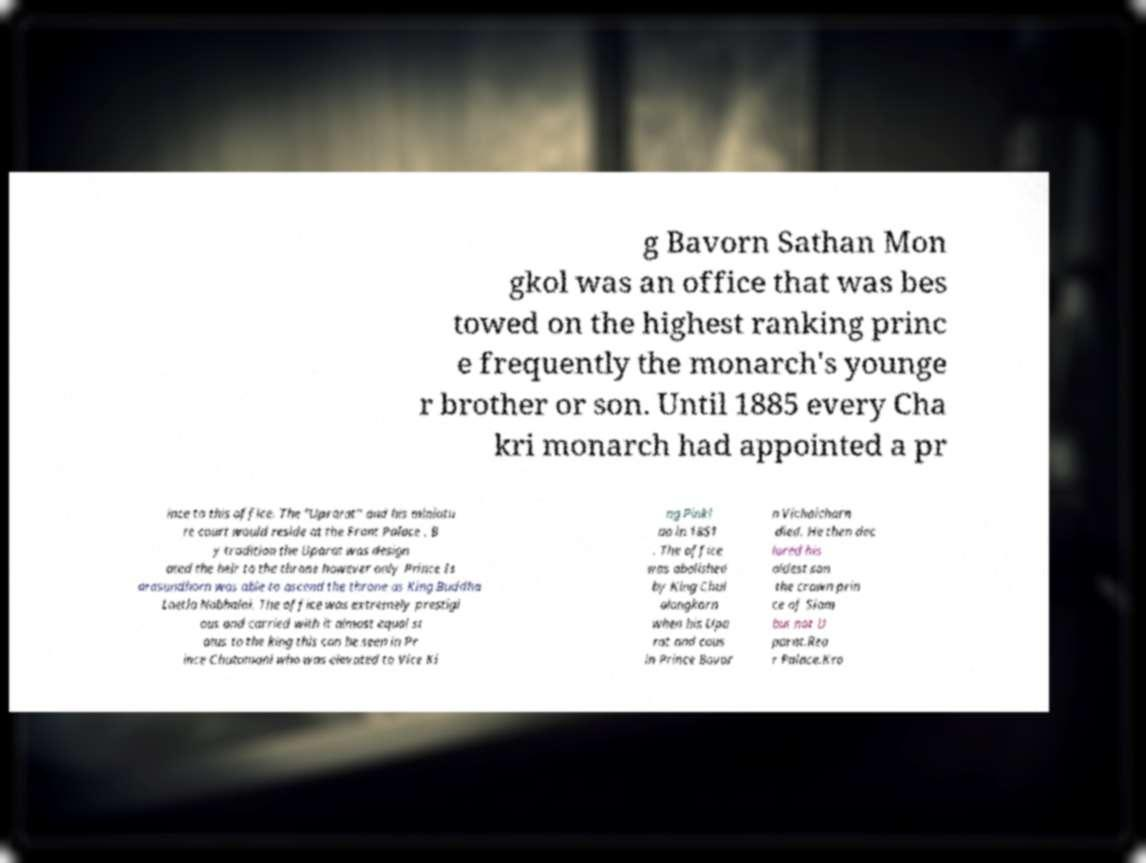Please read and relay the text visible in this image. What does it say? g Bavorn Sathan Mon gkol was an office that was bes towed on the highest ranking princ e frequently the monarch's younge r brother or son. Until 1885 every Cha kri monarch had appointed a pr ince to this office. The "Uprarat" and his miniatu re court would reside at the Front Palace . B y tradition the Uparat was design ated the heir to the throne however only Prince Is arasundhorn was able to ascend the throne as King Buddha Loetla Nabhalai. The office was extremely prestigi ous and carried with it almost equal st atus to the king this can be seen in Pr ince Chutamani who was elevated to Vice Ki ng Pinkl ao in 1851 . The office was abolished by King Chul alongkorn when his Upa rat and cous in Prince Bovor n Vichaicharn died. He then dec lared his oldest son the crown prin ce of Siam but not U parat.Rea r Palace.Kro 